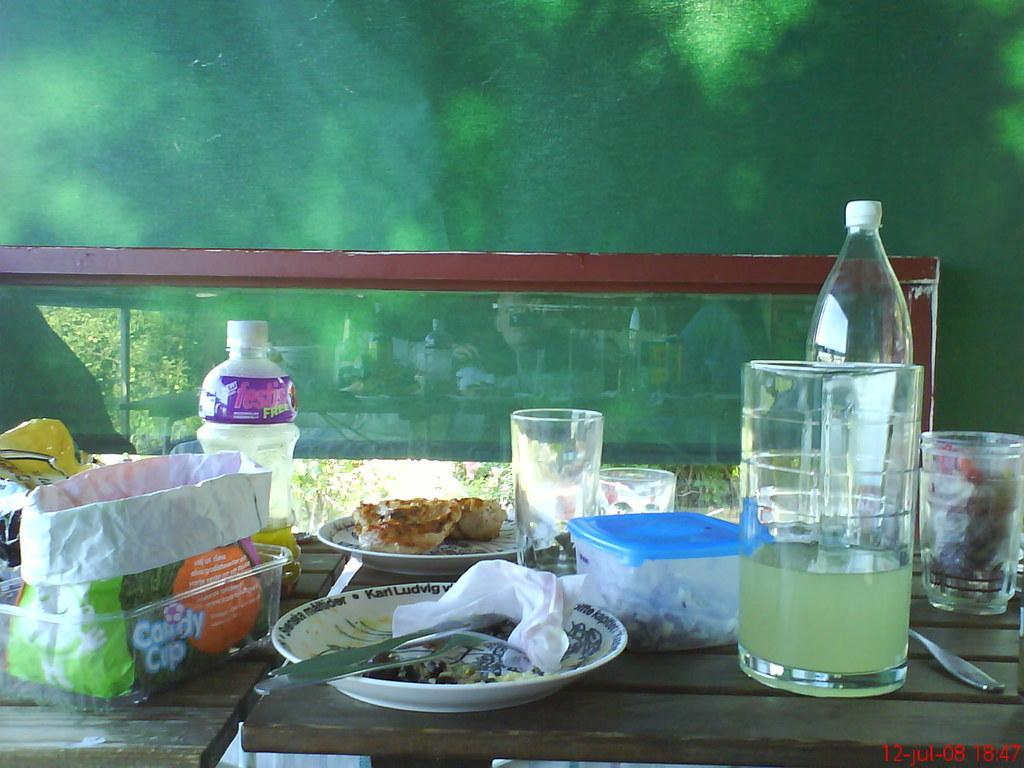Could you give a brief overview of what you see in this image? In this image there are tables, on the tables there are glasses, bowls, plates, a food item on one of the plates and some other objects, there is a small glass wall where there are reflections of the few objects on the table and few persons. 